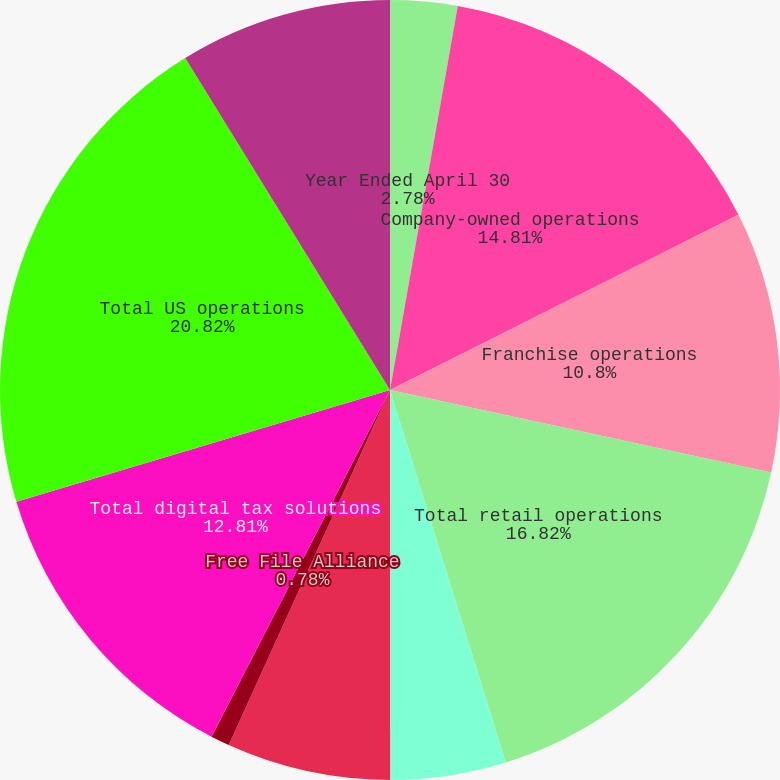Convert chart. <chart><loc_0><loc_0><loc_500><loc_500><pie_chart><fcel>Year Ended April 30<fcel>Company-owned operations<fcel>Franchise operations<fcel>Total retail operations<fcel>Software<fcel>Online<fcel>Free File Alliance<fcel>Total digital tax solutions<fcel>Total US operations<fcel>International operations<nl><fcel>2.78%<fcel>14.81%<fcel>10.8%<fcel>16.82%<fcel>4.79%<fcel>6.79%<fcel>0.78%<fcel>12.81%<fcel>20.83%<fcel>8.8%<nl></chart> 